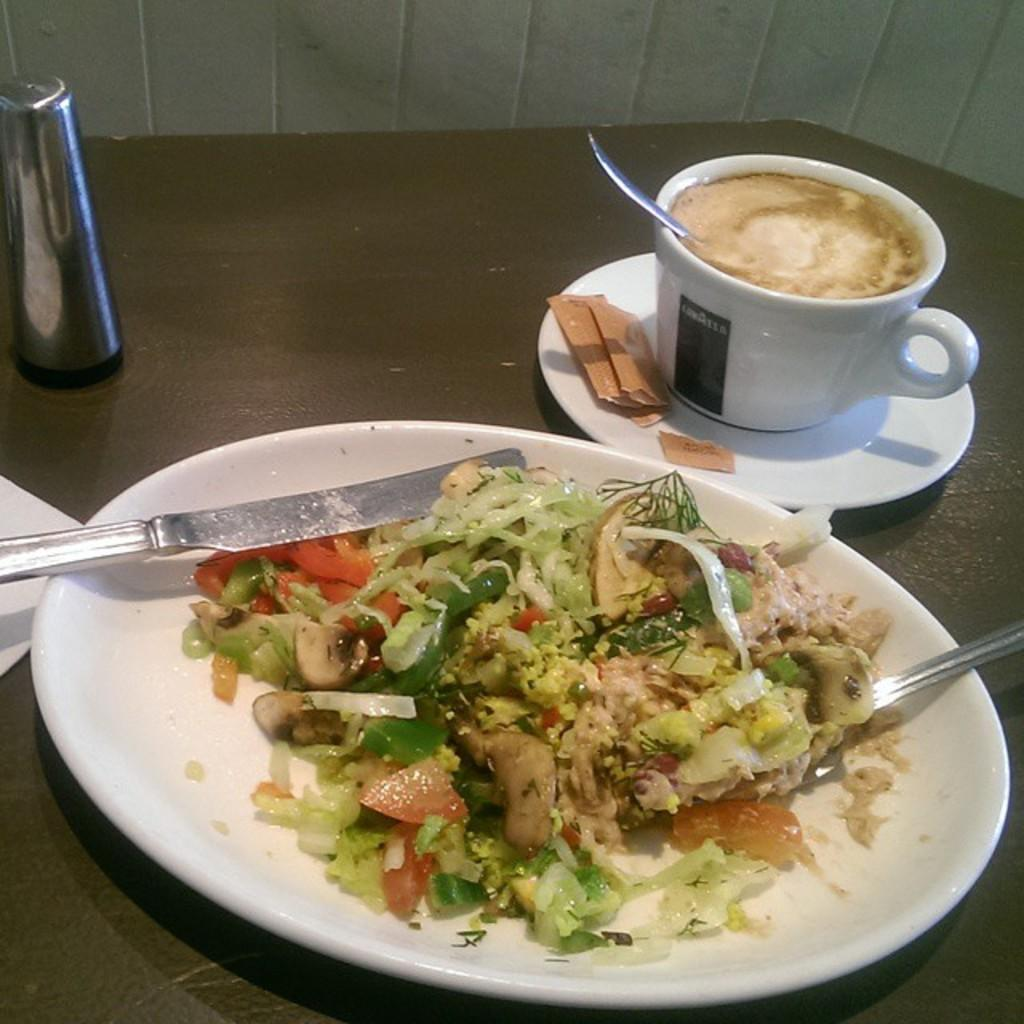What is present on the table in the image? There is a cup, a plate containing food and spoons, and the table in the image. What is the purpose of the cup and plate? The cup and plate are likely used for holding and serving food or beverages. Where is the container located in the image? The container is visible in the background of the image. What type of pie is the governor eating in the image? There is no governor or pie present in the image. 